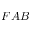<formula> <loc_0><loc_0><loc_500><loc_500>F A B</formula> 